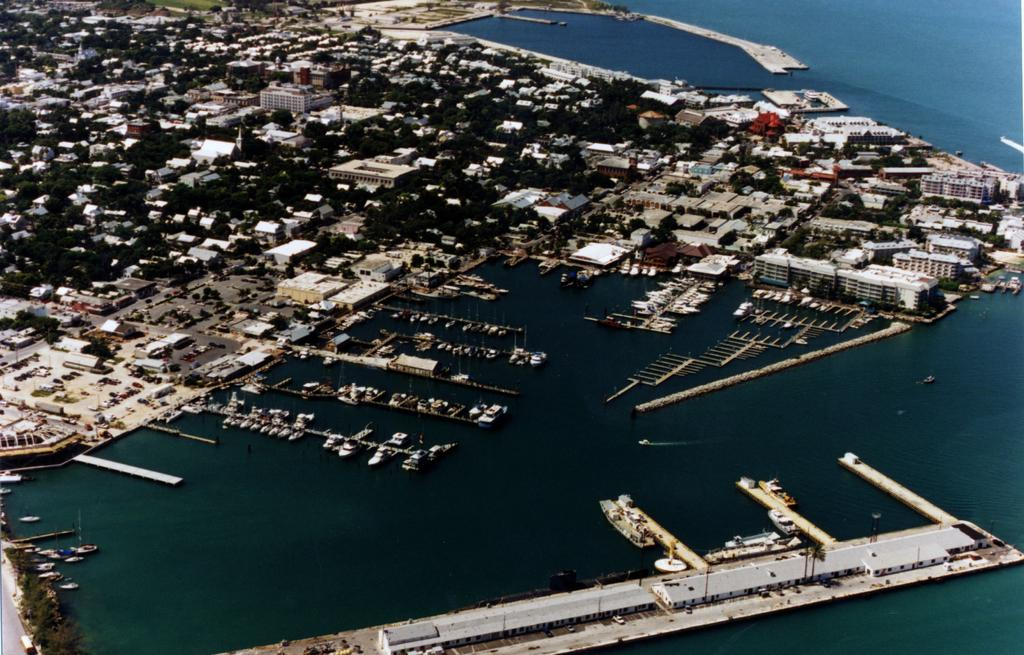What type of view is shown in the image? The image is a top view of a city. What can be seen in the city? There are many buildings in the city. What natural feature is visible in the image? There is seawater visible in the image. Where is the harbor stop located in the image? The harbor stop is in the front bottom side of the image. What is present at the harbor stop? There are ships at the harbor stop. How many members are on the committee in the image? There is no committee present in the image; it is a top view of a city with a harbor stop and ships. 